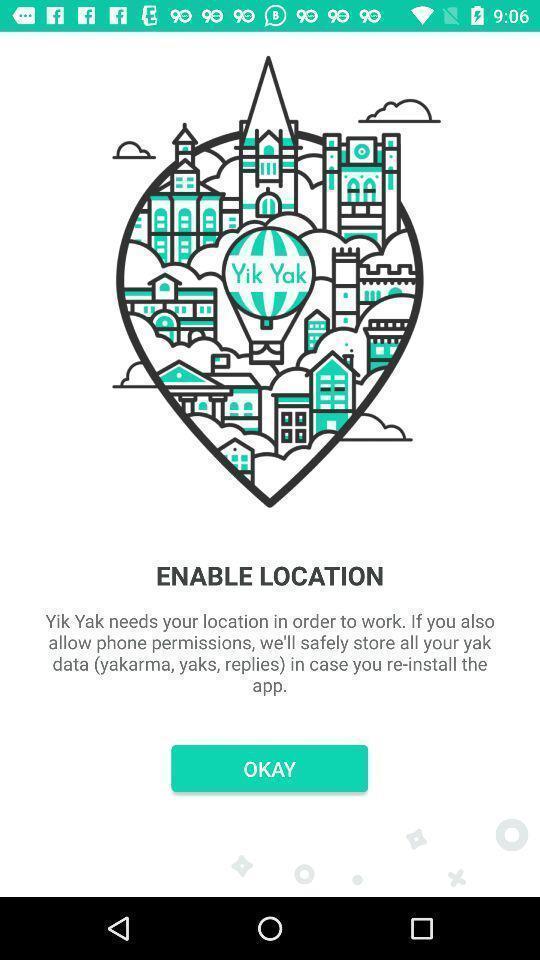Describe this image in words. Page with permission asking location enable. 